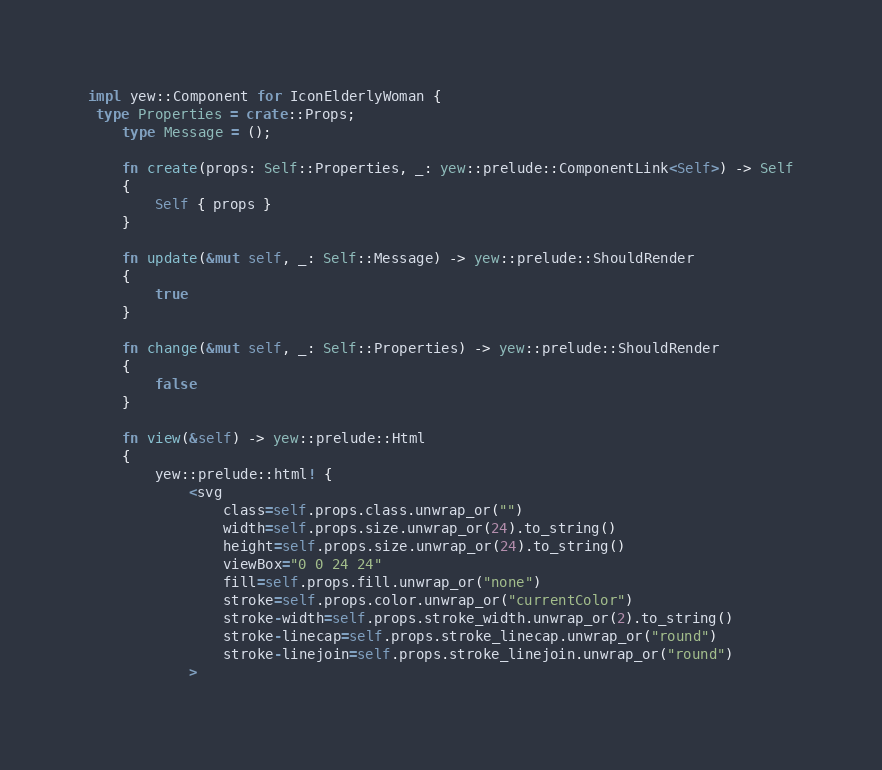Convert code to text. <code><loc_0><loc_0><loc_500><loc_500><_Rust_>
impl yew::Component for IconElderlyWoman {
 type Properties = crate::Props;
    type Message = ();

    fn create(props: Self::Properties, _: yew::prelude::ComponentLink<Self>) -> Self
    {
        Self { props }
    }

    fn update(&mut self, _: Self::Message) -> yew::prelude::ShouldRender
    {
        true
    }

    fn change(&mut self, _: Self::Properties) -> yew::prelude::ShouldRender
    {
        false
    }

    fn view(&self) -> yew::prelude::Html
    {
        yew::prelude::html! {
            <svg
                class=self.props.class.unwrap_or("")
                width=self.props.size.unwrap_or(24).to_string()
                height=self.props.size.unwrap_or(24).to_string()
                viewBox="0 0 24 24"
                fill=self.props.fill.unwrap_or("none")
                stroke=self.props.color.unwrap_or("currentColor")
                stroke-width=self.props.stroke_width.unwrap_or(2).to_string()
                stroke-linecap=self.props.stroke_linecap.unwrap_or("round")
                stroke-linejoin=self.props.stroke_linejoin.unwrap_or("round")
            ></code> 